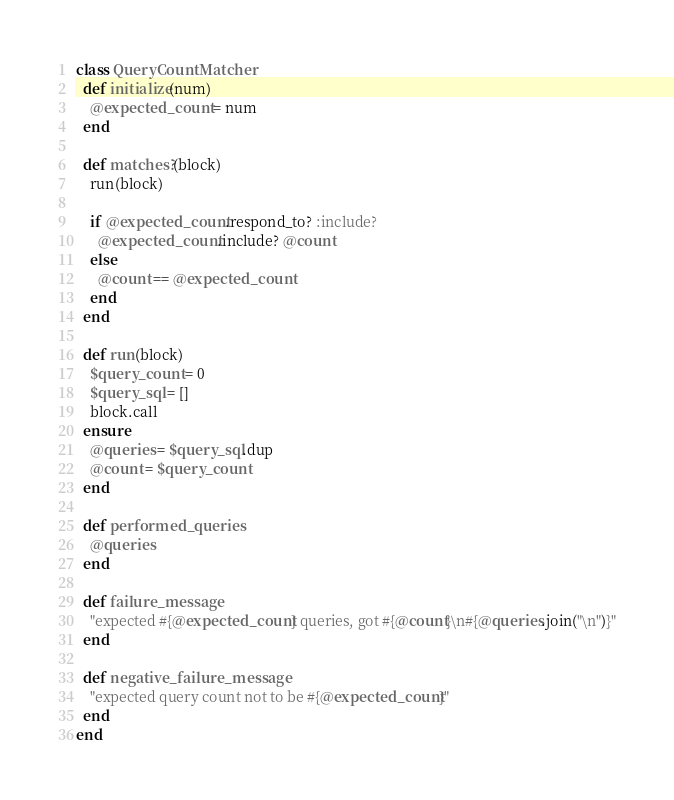Convert code to text. <code><loc_0><loc_0><loc_500><loc_500><_Ruby_>class QueryCountMatcher
  def initialize(num)
    @expected_count = num
  end

  def matches?(block)
    run(block)

    if @expected_count.respond_to? :include?
      @expected_count.include? @count
    else
      @count == @expected_count
    end
  end

  def run(block)
    $query_count = 0
    $query_sql = []
    block.call
  ensure
    @queries = $query_sql.dup
    @count = $query_count
  end

  def performed_queries
    @queries
  end

  def failure_message
    "expected #{@expected_count} queries, got #{@count}\n#{@queries.join("\n")}"
  end

  def negative_failure_message
    "expected query count not to be #{@expected_count}"
  end
end
</code> 